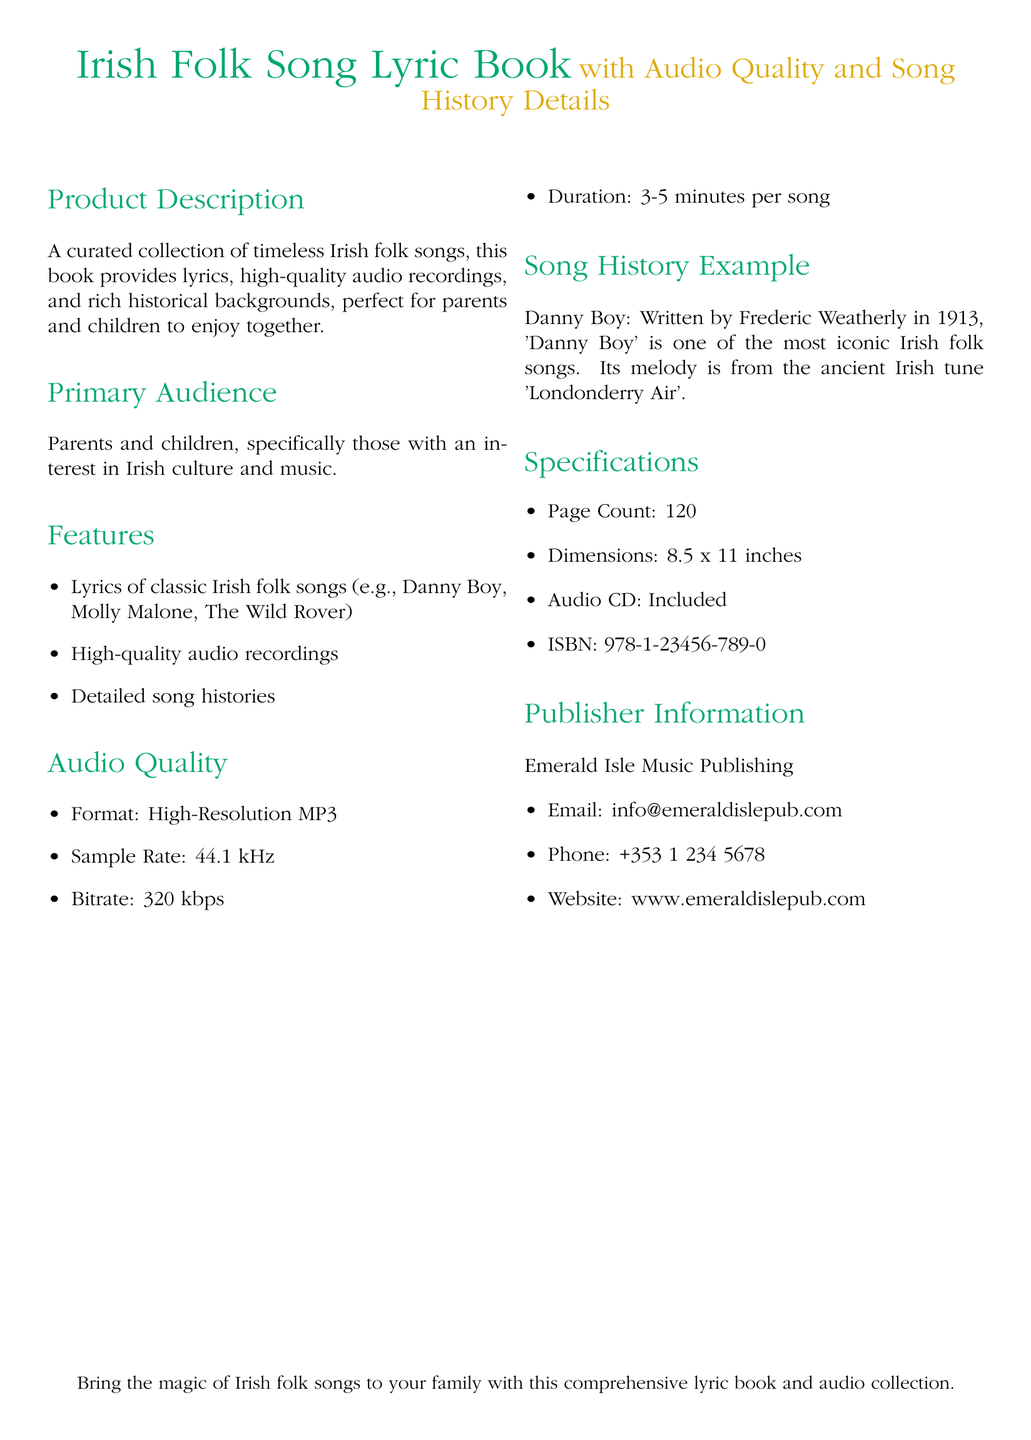What is the title of the book? The title is stated prominently at the top of the document.
Answer: Irish Folk Song Lyric Book What is the sample rate of the audio recordings? The sample rate is defined under the Audio Quality section.
Answer: 44.1 kHz How many pages does the book have? The page count is listed in the Specifications section.
Answer: 120 What is the ISBN of the book? The ISBN is mentioned in the Specifications section.
Answer: 978-1-23456-789-0 Who is the publisher of this book? The publisher is specified in the Publisher Information section.
Answer: Emerald Isle Music Publishing Which song is highlighted as an example in the song history? The song history example is presented in its own subsection.
Answer: Danny Boy What is the bitrate of the audio recordings? The bitrate can be found in the Audio Quality section.
Answer: 320 kbps What is the dimension of the book? The dimensions are located in the Specifications section.
Answer: 8.5 x 11 inches Who is the primary audience for this book? The primary audience is identified in its own section.
Answer: Parents and children 